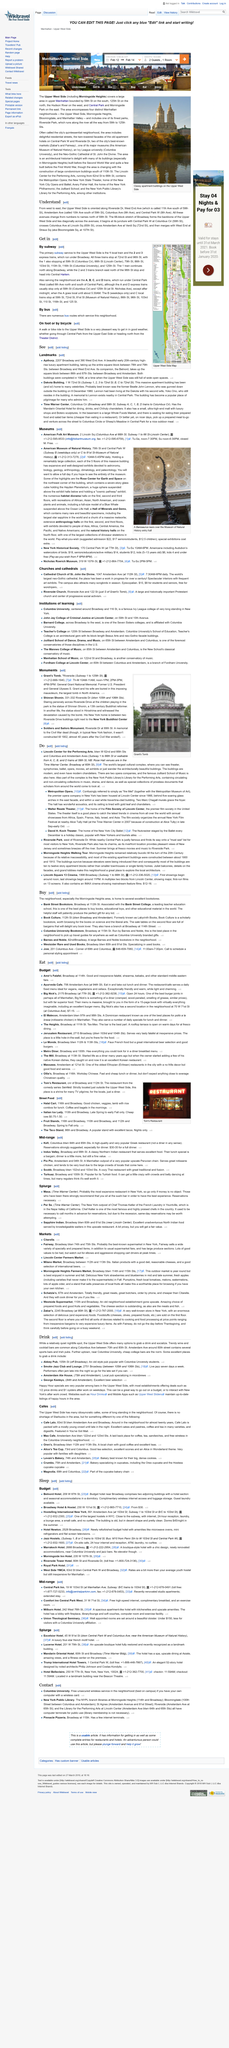Identify some key points in this picture. The Amsterdam Ale House caters to individuals who appreciate microbrews and offers a selection of quality microbrews. The Upper West Side is often referred to as the city's quintessential neighborhood. The photograph shows classy apartment buildings located on the Upper West Side. Milano Market is a market that provides a variety of Italian products, including reasonable cheeses. What is West End Avenue called? It is referred to as 11th Avenue. 